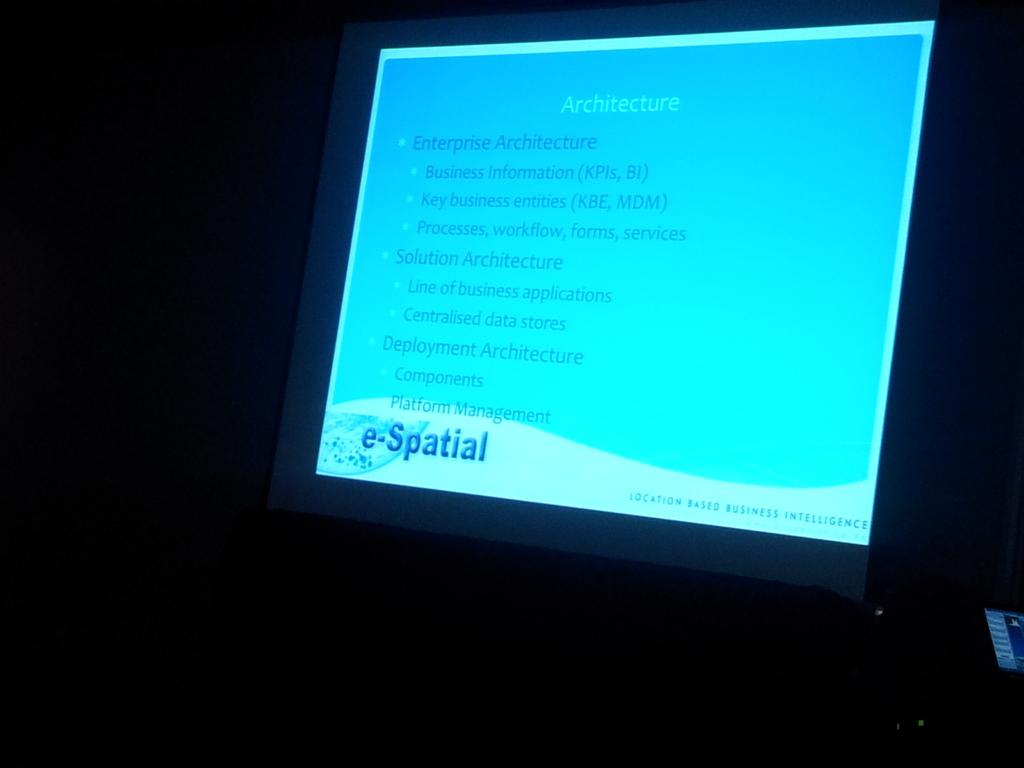<image>
Describe the image concisely. A power point presentation about Architecture with bullet points 